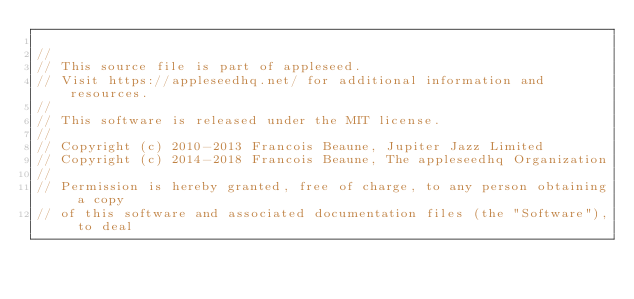Convert code to text. <code><loc_0><loc_0><loc_500><loc_500><_C++_>
//
// This source file is part of appleseed.
// Visit https://appleseedhq.net/ for additional information and resources.
//
// This software is released under the MIT license.
//
// Copyright (c) 2010-2013 Francois Beaune, Jupiter Jazz Limited
// Copyright (c) 2014-2018 Francois Beaune, The appleseedhq Organization
//
// Permission is hereby granted, free of charge, to any person obtaining a copy
// of this software and associated documentation files (the "Software"), to deal</code> 